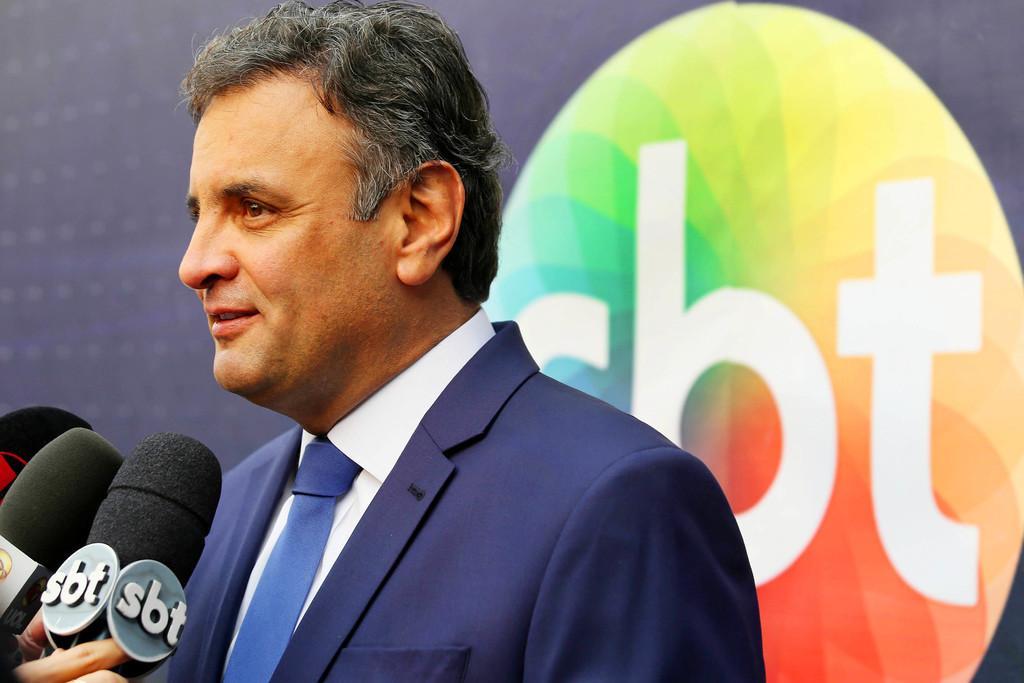Could you give a brief overview of what you see in this image? In this picture there is a man who is wearing blue suit. At the bottom left corner we can see person's hand who are holding mic. In the back we can see banner. 